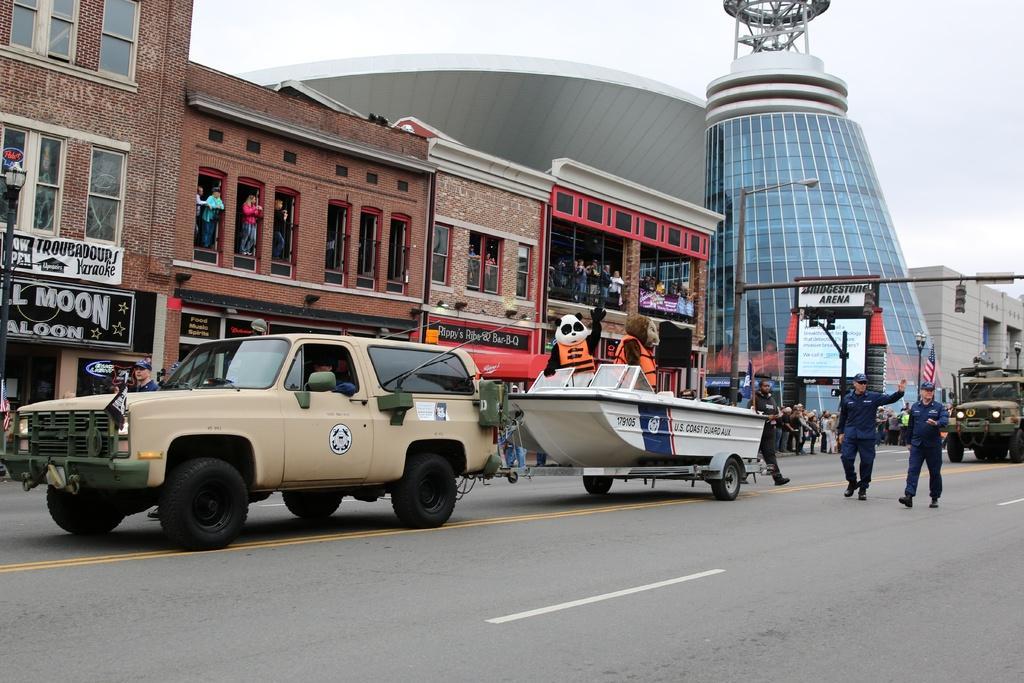Describe this image in one or two sentences. In this image I can see few vehicles on the road. I can also see few persons walking. The person in front wearing blue color dress, background I can see few buildings in brown and cream color and sky in white color. 